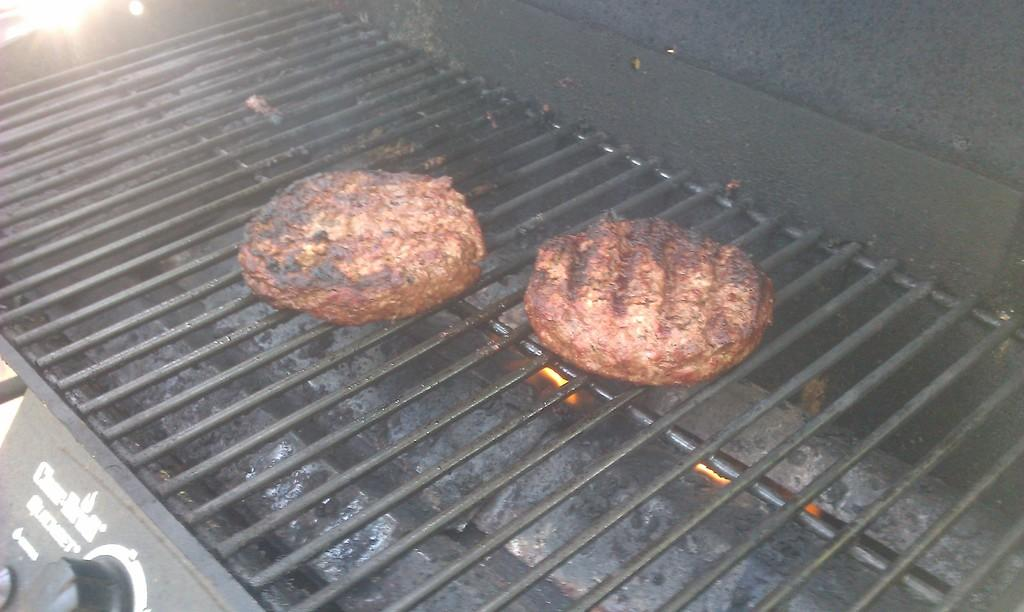What type of food is visible in the image? There are two pieces of meat in the image. How are the pieces of meat being prepared? The meat is placed on a grill. What device can be seen in the image that might be used to control the cooking process? There is a regulator in the image. What is the color of the regulator? The regulator is black in color. What type of clam is being grilled in the image? There are no clams present in the image; it features two pieces of meat on a grill. What is the position of the anger in the image? There is no anger present in the image; it is a photograph of meat on a grill and a black regulator. 